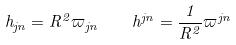<formula> <loc_0><loc_0><loc_500><loc_500>h _ { j n } = R ^ { 2 } \varpi _ { j n } \quad h ^ { j n } = \frac { 1 } { R ^ { 2 } } \varpi ^ { j n }</formula> 